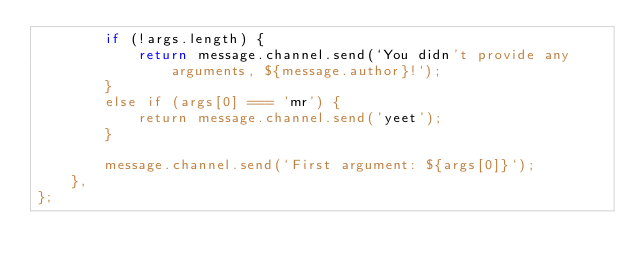Convert code to text. <code><loc_0><loc_0><loc_500><loc_500><_JavaScript_>		if (!args.length) {
			return message.channel.send(`You didn't provide any arguments, ${message.author}!`);
		}
		else if (args[0] === 'mr') {
			return message.channel.send('yeet');
		}
	
		message.channel.send(`First argument: ${args[0]}`);
	},
};</code> 